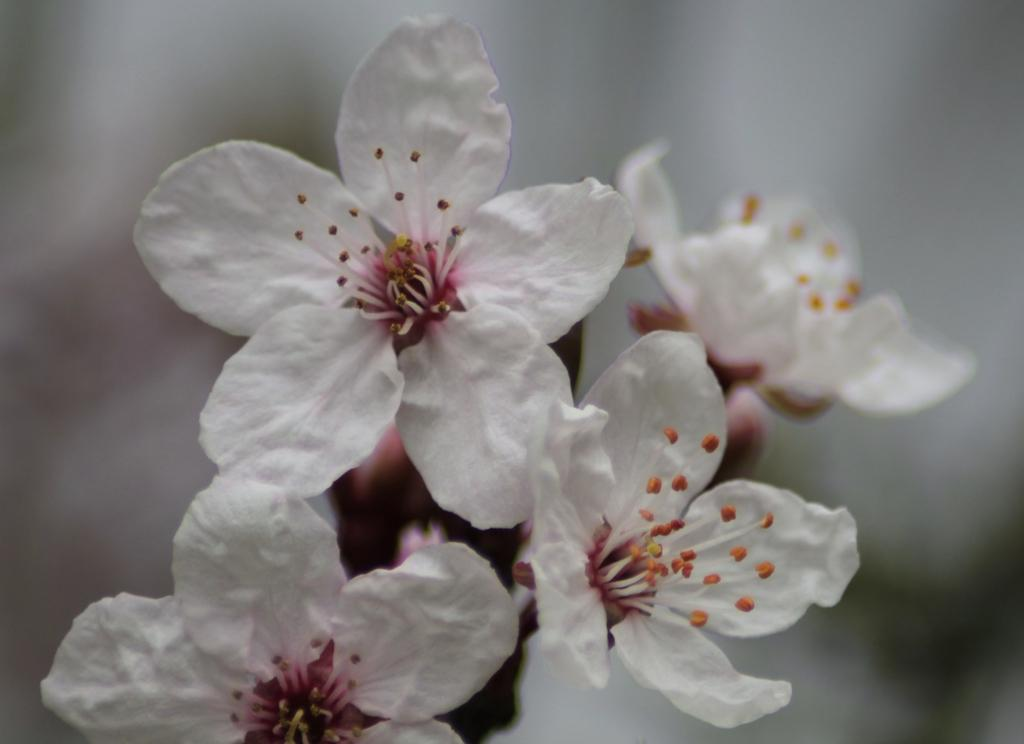What type of flowers can be seen in the image? There are white color flowers in the image. What type of poison is being used to plot against the flowers in the image? There is no indication of any poison or plot against the flowers in the image; it simply shows white color flowers. 